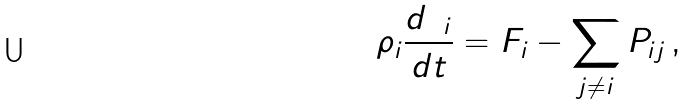Convert formula to latex. <formula><loc_0><loc_0><loc_500><loc_500>\rho _ { i } \frac { d { \mathbf v } _ { i } } { d t } = { F } _ { i } - \sum _ { j \neq i } { P } _ { i j } \, ,</formula> 